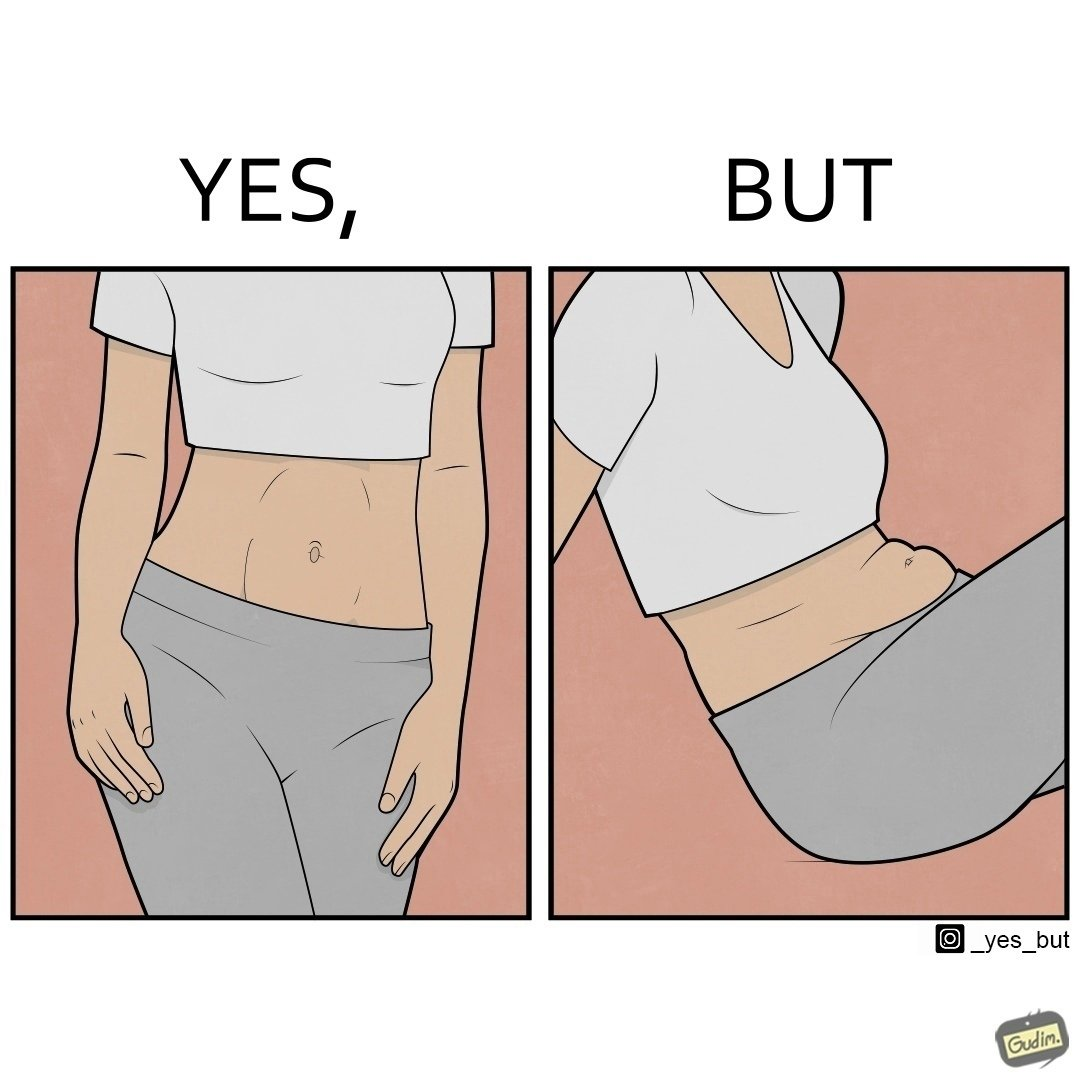Is this a satirical image? Yes, this image is satirical. 